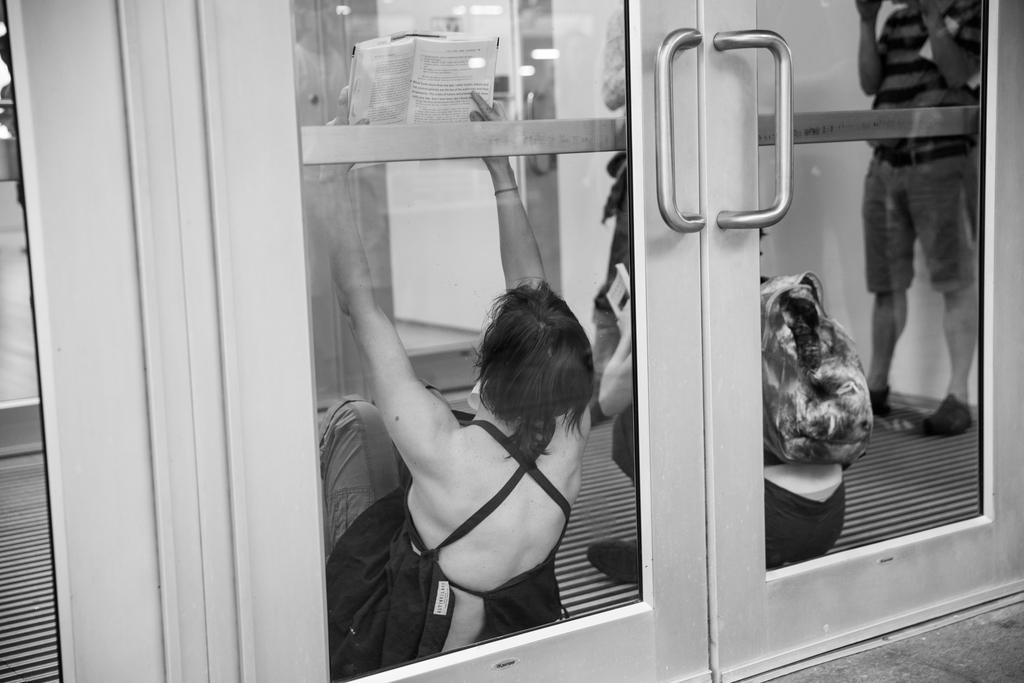Please provide a concise description of this image. In this picture we can see glass doors, from glass doors we can see people, one woman is holding a book. 